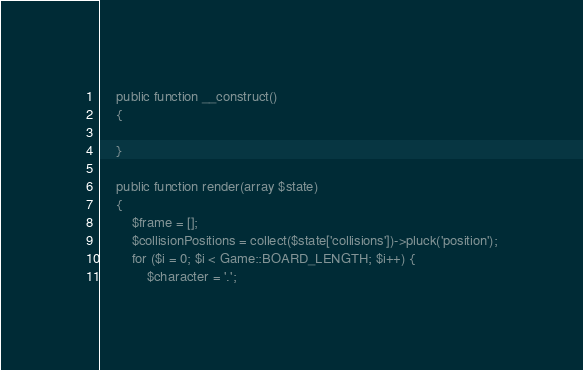Convert code to text. <code><loc_0><loc_0><loc_500><loc_500><_PHP_>    public function __construct()
    {

    }

    public function render(array $state)
    {
        $frame = [];
        $collisionPositions = collect($state['collisions'])->pluck('position');
        for ($i = 0; $i < Game::BOARD_LENGTH; $i++) {
            $character = '.';</code> 